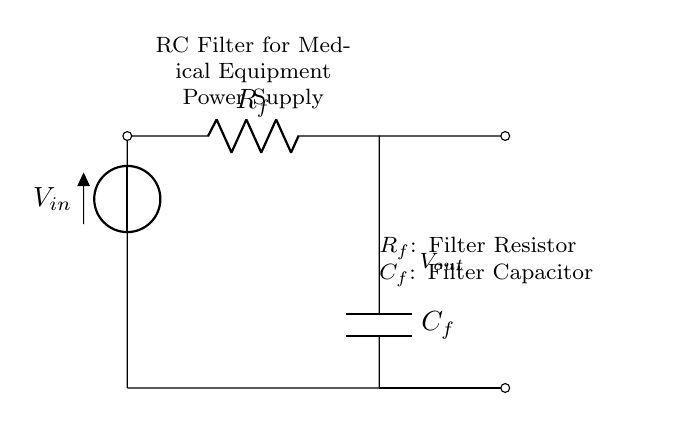What is the input voltage? The input voltage, labeled as V_in, is the voltage supplied to the circuit from an external source. It is represented at the top of the circuit diagram.
Answer: V_in What components form this RC filter? The components in this RC filter are a resistor and a capacitor, indicated by R_f and C_f in the diagram.
Answer: R_f and C_f What is the purpose of the resistor in this circuit? The resistor (R_f) is used to limit current flow and contribute to the voltage drop across it, making it an essential part of the filtering process.
Answer: To limit current flow What is the output voltage measured across? The output voltage (V_out) is measured across the capacitor (C_f) in this RC circuit. It reflects the voltage after filtering.
Answer: C_f What is the function of the capacitor in this filter? The capacitor (C_f) in this circuit stores energy and smooths out fluctuations in the voltage, providing a more stable output.
Answer: To smooth voltage fluctuations How does the RC time constant affect the filtering action? The RC time constant, calculated as the product of the resistance (R_f) and capacitance (C_f), determines how quickly the circuit responds to changes in voltage. A larger time constant means slower response.
Answer: It determines the response time 